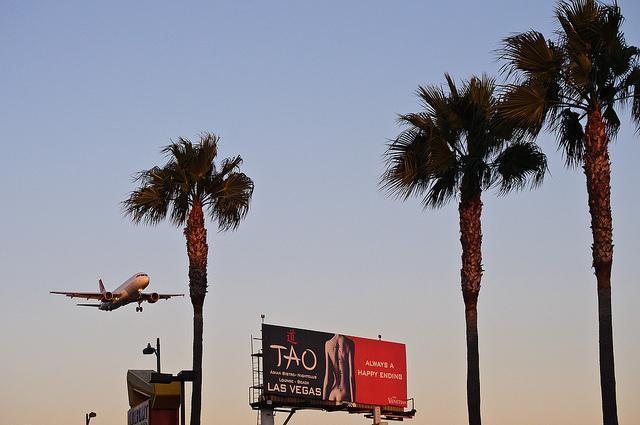How many palm trees do you see?
Give a very brief answer. 3. How many types of equipment that utilize wind are featured in the picture?
Give a very brief answer. 1. How many boards are there?
Give a very brief answer. 1. How many bears are waving?
Give a very brief answer. 0. 